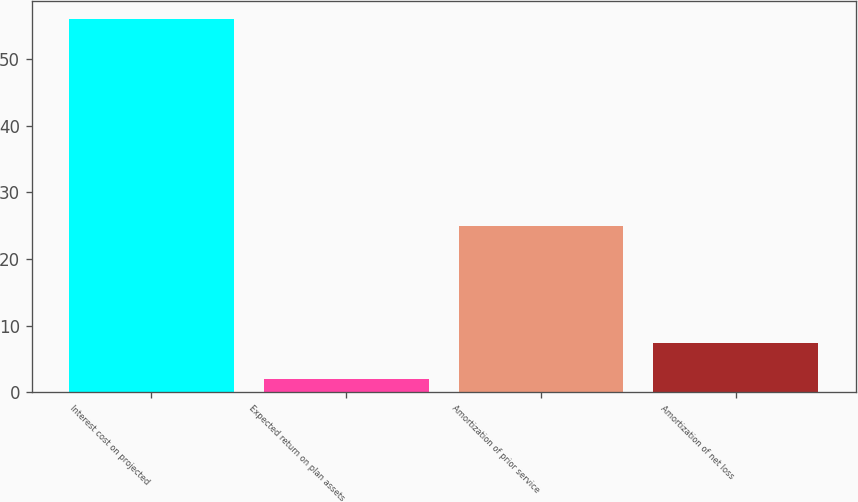Convert chart to OTSL. <chart><loc_0><loc_0><loc_500><loc_500><bar_chart><fcel>Interest cost on projected<fcel>Expected return on plan assets<fcel>Amortization of prior service<fcel>Amortization of net loss<nl><fcel>56<fcel>2<fcel>25<fcel>7.4<nl></chart> 